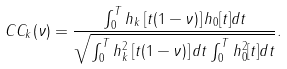Convert formula to latex. <formula><loc_0><loc_0><loc_500><loc_500>C C _ { k } ( \nu ) = \frac { \int _ { 0 } ^ { T } h _ { k } \left [ t ( 1 - \nu ) \right ] h _ { 0 } [ t ] d t } { \sqrt { \int _ { 0 } ^ { T } h _ { k } ^ { 2 } \left [ t ( 1 - \nu ) \right ] d t \int _ { 0 } ^ { T } h _ { 0 } ^ { 2 } [ t ] d t } } .</formula> 